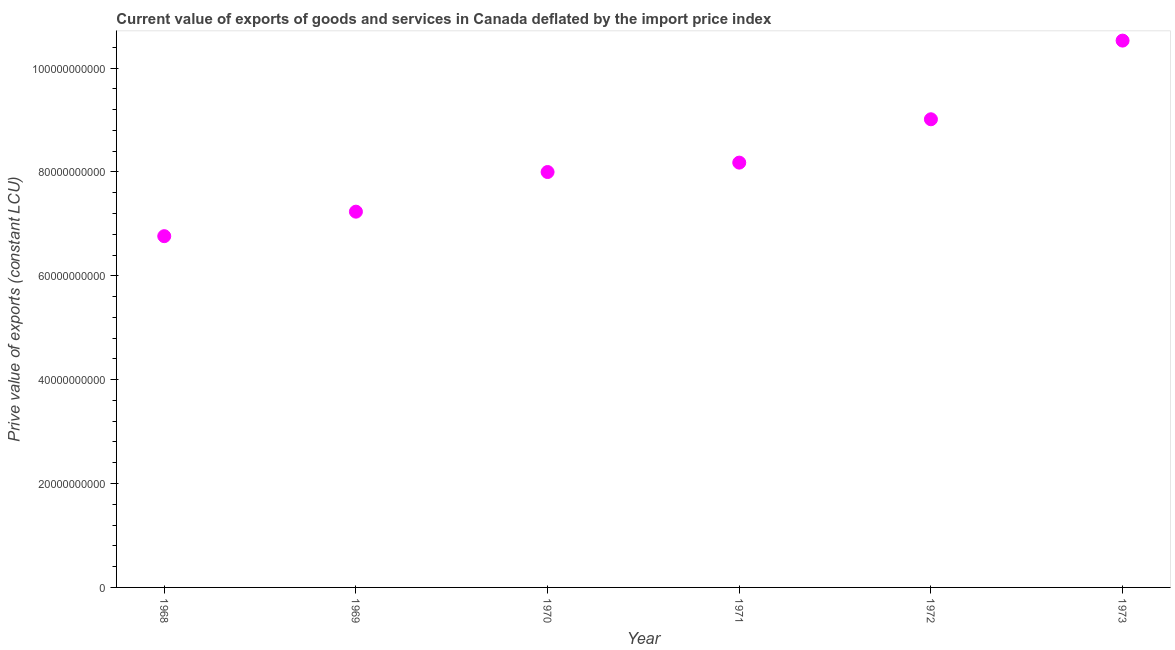What is the price value of exports in 1973?
Your answer should be very brief. 1.05e+11. Across all years, what is the maximum price value of exports?
Provide a short and direct response. 1.05e+11. Across all years, what is the minimum price value of exports?
Provide a succinct answer. 6.76e+1. In which year was the price value of exports maximum?
Offer a very short reply. 1973. In which year was the price value of exports minimum?
Your response must be concise. 1968. What is the sum of the price value of exports?
Make the answer very short. 4.97e+11. What is the difference between the price value of exports in 1969 and 1971?
Ensure brevity in your answer.  -9.44e+09. What is the average price value of exports per year?
Keep it short and to the point. 8.29e+1. What is the median price value of exports?
Give a very brief answer. 8.09e+1. What is the ratio of the price value of exports in 1969 to that in 1972?
Keep it short and to the point. 0.8. Is the difference between the price value of exports in 1971 and 1972 greater than the difference between any two years?
Provide a short and direct response. No. What is the difference between the highest and the second highest price value of exports?
Keep it short and to the point. 1.51e+1. Is the sum of the price value of exports in 1968 and 1971 greater than the maximum price value of exports across all years?
Keep it short and to the point. Yes. What is the difference between the highest and the lowest price value of exports?
Your answer should be very brief. 3.77e+1. Does the price value of exports monotonically increase over the years?
Give a very brief answer. Yes. How many dotlines are there?
Keep it short and to the point. 1. How many years are there in the graph?
Give a very brief answer. 6. What is the difference between two consecutive major ticks on the Y-axis?
Your answer should be very brief. 2.00e+1. Are the values on the major ticks of Y-axis written in scientific E-notation?
Make the answer very short. No. What is the title of the graph?
Offer a very short reply. Current value of exports of goods and services in Canada deflated by the import price index. What is the label or title of the Y-axis?
Your answer should be compact. Prive value of exports (constant LCU). What is the Prive value of exports (constant LCU) in 1968?
Provide a succinct answer. 6.76e+1. What is the Prive value of exports (constant LCU) in 1969?
Provide a short and direct response. 7.23e+1. What is the Prive value of exports (constant LCU) in 1970?
Ensure brevity in your answer.  8.00e+1. What is the Prive value of exports (constant LCU) in 1971?
Keep it short and to the point. 8.18e+1. What is the Prive value of exports (constant LCU) in 1972?
Provide a short and direct response. 9.01e+1. What is the Prive value of exports (constant LCU) in 1973?
Offer a very short reply. 1.05e+11. What is the difference between the Prive value of exports (constant LCU) in 1968 and 1969?
Your response must be concise. -4.72e+09. What is the difference between the Prive value of exports (constant LCU) in 1968 and 1970?
Your answer should be compact. -1.23e+1. What is the difference between the Prive value of exports (constant LCU) in 1968 and 1971?
Make the answer very short. -1.42e+1. What is the difference between the Prive value of exports (constant LCU) in 1968 and 1972?
Your answer should be very brief. -2.25e+1. What is the difference between the Prive value of exports (constant LCU) in 1968 and 1973?
Your response must be concise. -3.77e+1. What is the difference between the Prive value of exports (constant LCU) in 1969 and 1970?
Your answer should be compact. -7.63e+09. What is the difference between the Prive value of exports (constant LCU) in 1969 and 1971?
Offer a very short reply. -9.44e+09. What is the difference between the Prive value of exports (constant LCU) in 1969 and 1972?
Offer a terse response. -1.78e+1. What is the difference between the Prive value of exports (constant LCU) in 1969 and 1973?
Offer a terse response. -3.29e+1. What is the difference between the Prive value of exports (constant LCU) in 1970 and 1971?
Provide a succinct answer. -1.81e+09. What is the difference between the Prive value of exports (constant LCU) in 1970 and 1972?
Provide a short and direct response. -1.02e+1. What is the difference between the Prive value of exports (constant LCU) in 1970 and 1973?
Provide a succinct answer. -2.53e+1. What is the difference between the Prive value of exports (constant LCU) in 1971 and 1972?
Provide a succinct answer. -8.35e+09. What is the difference between the Prive value of exports (constant LCU) in 1971 and 1973?
Your answer should be compact. -2.35e+1. What is the difference between the Prive value of exports (constant LCU) in 1972 and 1973?
Ensure brevity in your answer.  -1.51e+1. What is the ratio of the Prive value of exports (constant LCU) in 1968 to that in 1969?
Your answer should be very brief. 0.94. What is the ratio of the Prive value of exports (constant LCU) in 1968 to that in 1970?
Provide a short and direct response. 0.85. What is the ratio of the Prive value of exports (constant LCU) in 1968 to that in 1971?
Keep it short and to the point. 0.83. What is the ratio of the Prive value of exports (constant LCU) in 1968 to that in 1973?
Make the answer very short. 0.64. What is the ratio of the Prive value of exports (constant LCU) in 1969 to that in 1970?
Provide a succinct answer. 0.91. What is the ratio of the Prive value of exports (constant LCU) in 1969 to that in 1971?
Keep it short and to the point. 0.89. What is the ratio of the Prive value of exports (constant LCU) in 1969 to that in 1972?
Give a very brief answer. 0.8. What is the ratio of the Prive value of exports (constant LCU) in 1969 to that in 1973?
Provide a succinct answer. 0.69. What is the ratio of the Prive value of exports (constant LCU) in 1970 to that in 1972?
Your response must be concise. 0.89. What is the ratio of the Prive value of exports (constant LCU) in 1970 to that in 1973?
Your response must be concise. 0.76. What is the ratio of the Prive value of exports (constant LCU) in 1971 to that in 1972?
Your answer should be compact. 0.91. What is the ratio of the Prive value of exports (constant LCU) in 1971 to that in 1973?
Keep it short and to the point. 0.78. What is the ratio of the Prive value of exports (constant LCU) in 1972 to that in 1973?
Keep it short and to the point. 0.86. 